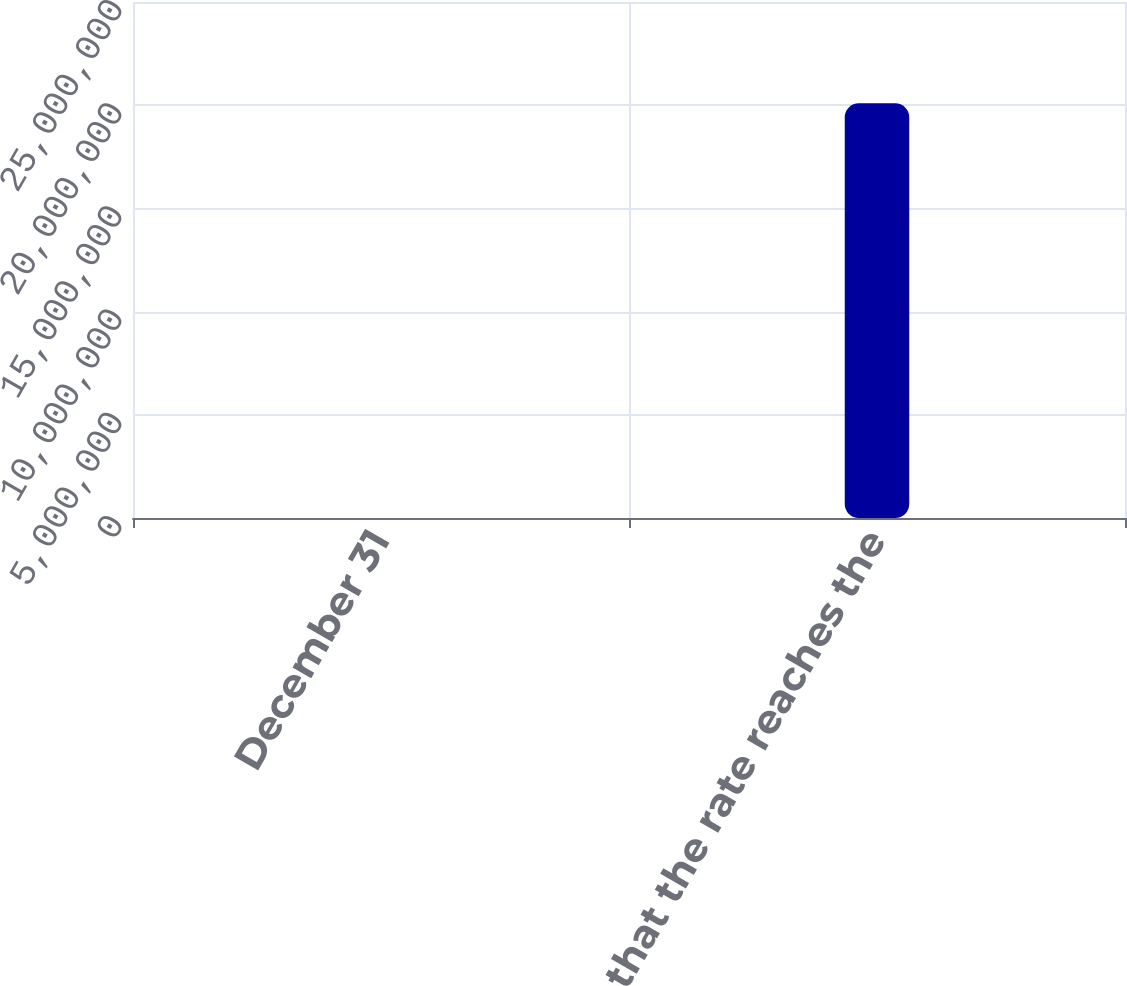<chart> <loc_0><loc_0><loc_500><loc_500><bar_chart><fcel>December 31<fcel>Year that the rate reaches the<nl><fcel>2008<fcel>2.0092e+07<nl></chart> 